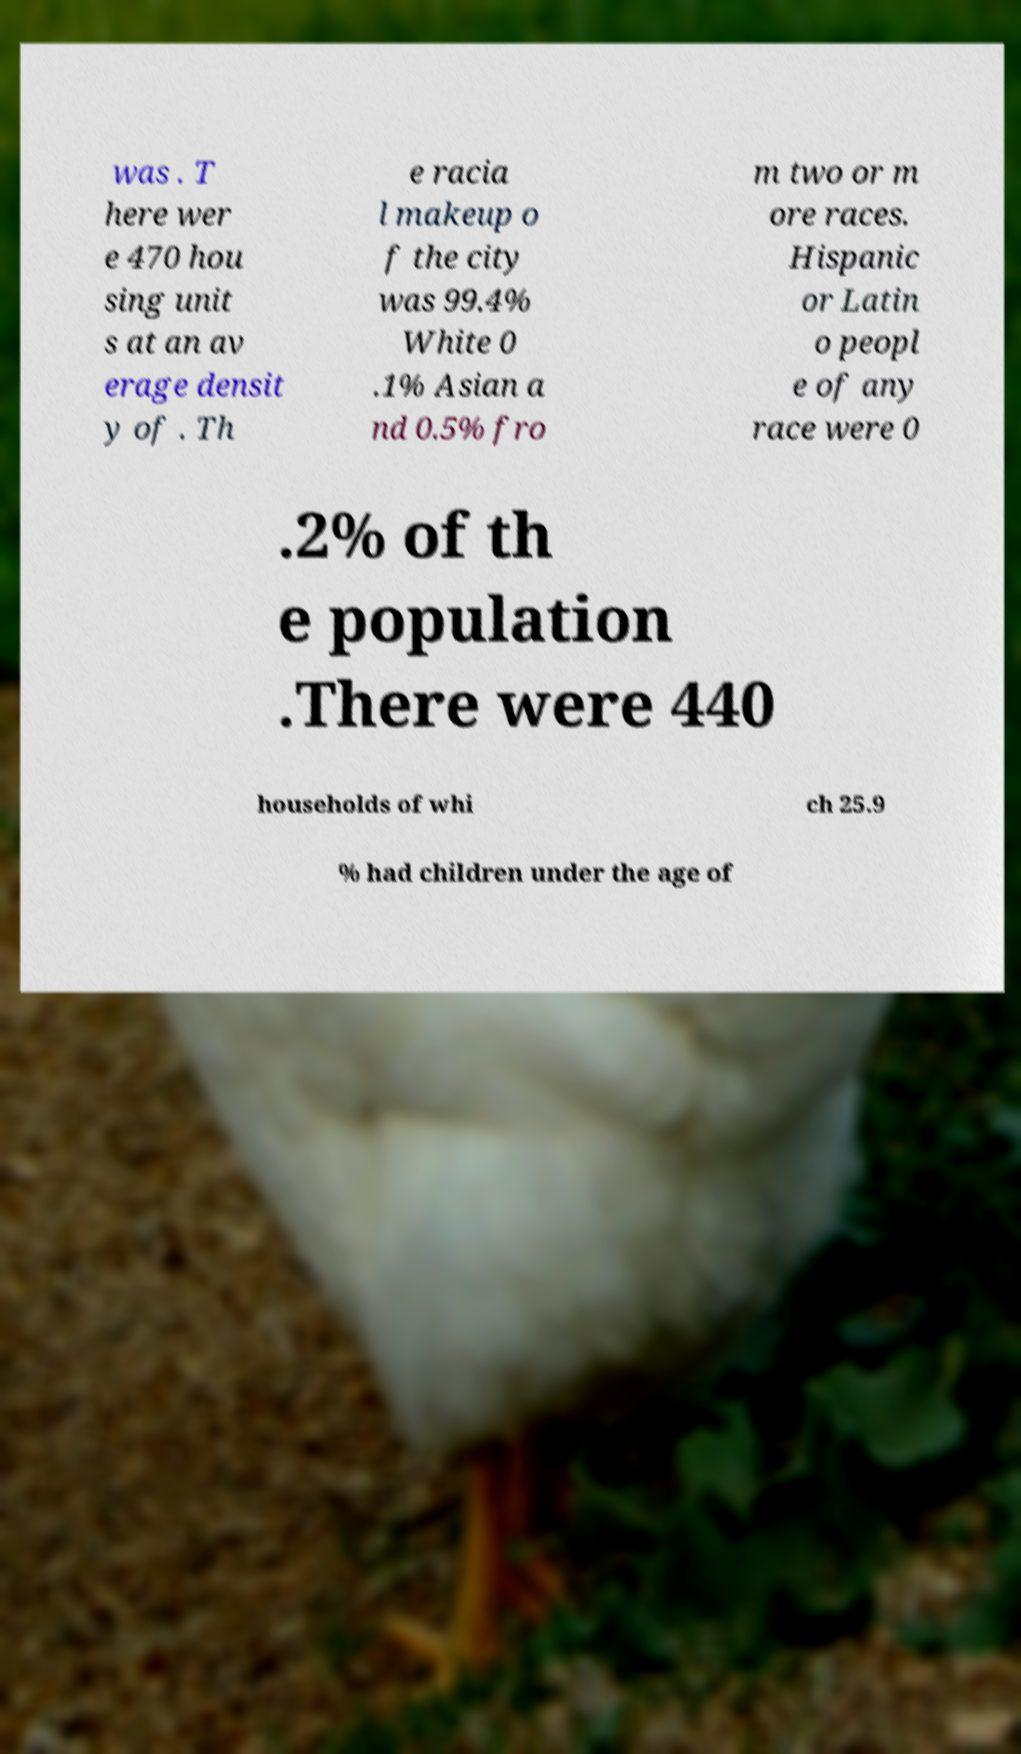I need the written content from this picture converted into text. Can you do that? was . T here wer e 470 hou sing unit s at an av erage densit y of . Th e racia l makeup o f the city was 99.4% White 0 .1% Asian a nd 0.5% fro m two or m ore races. Hispanic or Latin o peopl e of any race were 0 .2% of th e population .There were 440 households of whi ch 25.9 % had children under the age of 